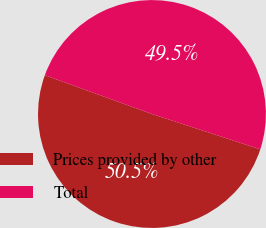Convert chart to OTSL. <chart><loc_0><loc_0><loc_500><loc_500><pie_chart><fcel>Prices provided by other<fcel>Total<nl><fcel>50.51%<fcel>49.49%<nl></chart> 